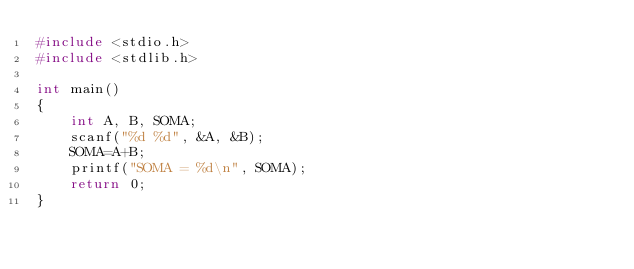Convert code to text. <code><loc_0><loc_0><loc_500><loc_500><_C_>#include <stdio.h>
#include <stdlib.h>

int main()
{
    int A, B, SOMA;
    scanf("%d %d", &A, &B);
    SOMA=A+B;
    printf("SOMA = %d\n", SOMA);
    return 0;
}
</code> 